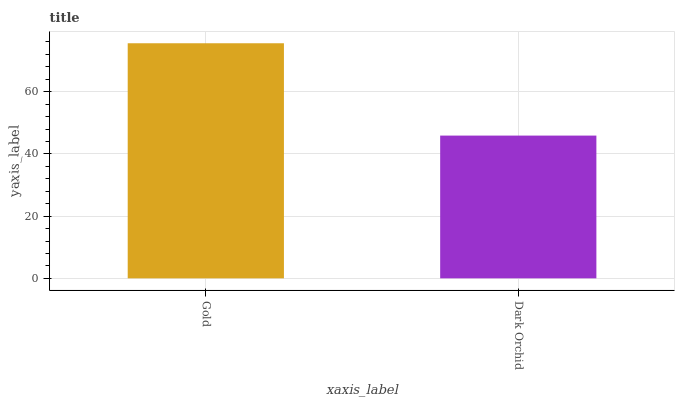Is Dark Orchid the minimum?
Answer yes or no. Yes. Is Gold the maximum?
Answer yes or no. Yes. Is Dark Orchid the maximum?
Answer yes or no. No. Is Gold greater than Dark Orchid?
Answer yes or no. Yes. Is Dark Orchid less than Gold?
Answer yes or no. Yes. Is Dark Orchid greater than Gold?
Answer yes or no. No. Is Gold less than Dark Orchid?
Answer yes or no. No. Is Gold the high median?
Answer yes or no. Yes. Is Dark Orchid the low median?
Answer yes or no. Yes. Is Dark Orchid the high median?
Answer yes or no. No. Is Gold the low median?
Answer yes or no. No. 